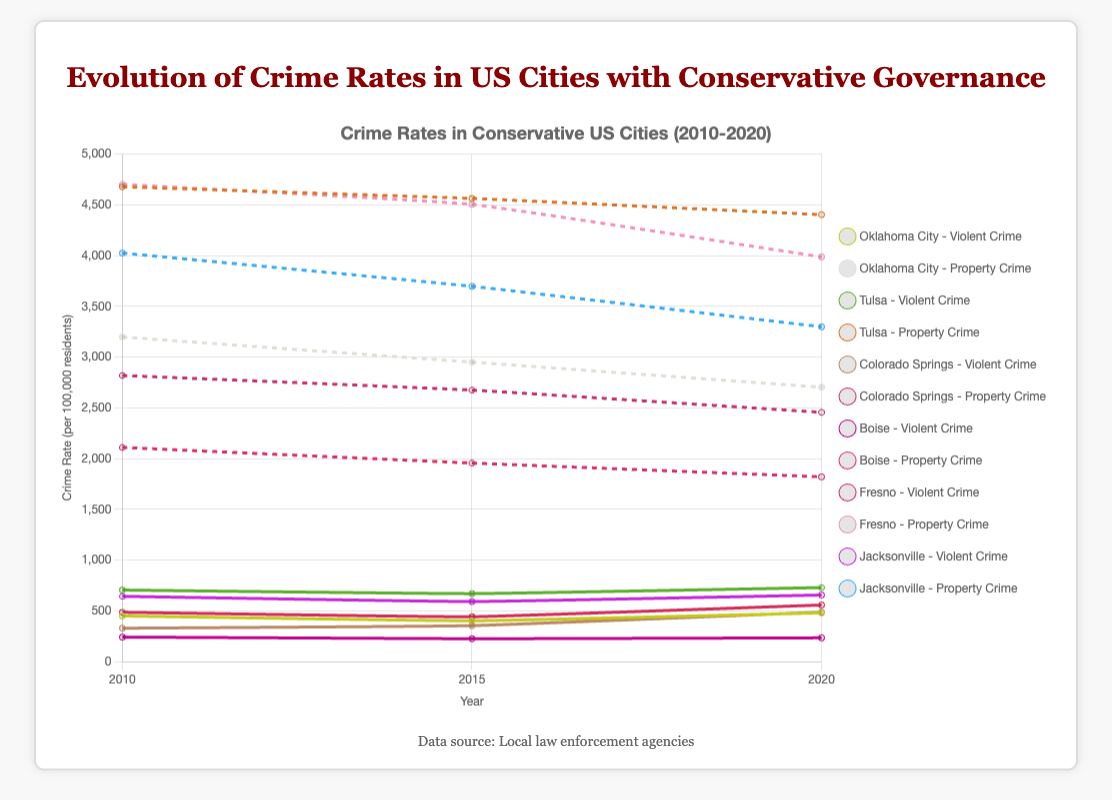What is the trend of violent crime rates in Oklahoma City from 2010 to 2020? To get the trend, look at the violent crime rates for Oklahoma City in 2010, 2015, and 2020. The values are 450.3, 403.2, and 480.6, respectively. From 2010 to 2015, the violent crime rate decreased from 450.3 to 403.2, then increased to 480.6 by 2020.
Answer: Decreased then increased Which city had the highest property crime rate in 2020? To determine this, compare the property crime rates of all cities in 2020. Oklahoma City has 2703.5, Tulsa has 4402.9, Colorado Springs has 2456.2, Boise has 1820.7, Fresno has 3987.6, and Jacksonville has 3298.9. The highest is Tulsa with 4402.9.
Answer: Tulsa How did the property crime rate in Boise change from 2010 to 2020? Compare the property crime rates in Boise for 2010, 2015, and 2020. The values are 2110.4, 1956.5, and 1820.7, respectively. This shows a continuous decrease over the years.
Answer: Decreased Which city showed the most significant increase in violent crime rate from 2015 to 2020? Calculate the difference in violent crime rates from 2015 to 2020 for each city. Oklahoma City increased by 77.4 (480.6 - 403.2), Tulsa increased by 59.5 (729.9 - 670.4), Colorado Springs increased by 132.4 (487.6 - 355.2), Boise increased by 8.6 (234.9 - 226.3), Fresno increased by 115.3 (558.2 - 442.9), Jacksonville increased by 64.2 (656.6 - 592.4). Colorado Springs had the largest increase, 132.4.
Answer: Colorado Springs Compare the violent crime rates of Tulsa and Jacksonville in 2010. Which city had a higher rate? Look at the violent crime rates for Tulsa and Jacksonville in 2010. Tulsa's rate is 705.7 and Jacksonville's is 643.7. Tulsa had the higher rate.
Answer: Tulsa What is the average property crime rate in Colorado Springs over the years 2010, 2015, and 2020? Sum the property crime rates for Colorado Springs over the three years and divide by the number of years. The rates are 2819.3, 2675.1, and 2456.2. The sum is (2819.3 + 2675.1 + 2456.2) = 7949.6. Divide by 3, the average is 7949.6 / 3 ≈ 2649.9.
Answer: 2649.9 Which city had the smallest decrease in property crime rate from 2010 to 2020? Calculate the difference in property crime rates from 2010 to 2020 for each city and find the smallest value. Oklahoma City decreased by 494.9 (3198.4 - 2703.5), Tulsa decreased by 275.1 (4678.0 - 4402.9), Colorado Springs decreased by 363.1 (2819.3 - 2456.2), Boise decreased by 289.7 (2110.4 - 1820.7), Fresno decreased by 714.3 (4701.9 - 3987.6), Jacksonville decreased by 726.4 (4025.3 - 3298.9). Tulsa had the smallest decrease of 275.1.
Answer: Tulsa How does the trend in violent crime rates in Boise compare to the trend in property crime rates from 2010 to 2020? Look at Boise's data from 2010, 2015, and 2020. Violent crime rates: 242.2, 226.3, and 234.9. Property crime rates: 2110.4, 1956.5, 1820.7. Violent crime rates showed a decrease from 2010 to 2015 and a slight increase to 2020, whereas property crime rates consistently decreased over the period.
Answer: Violent: Decreased then increased, Property: Decreased 